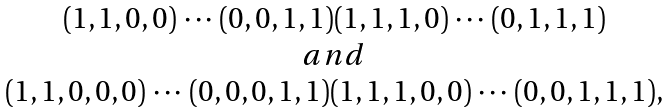Convert formula to latex. <formula><loc_0><loc_0><loc_500><loc_500>\begin{array} { c } ( 1 , 1 , 0 , 0 ) \, \cdots \, ( 0 , 0 , 1 , 1 ) ( 1 , 1 , 1 , 0 ) \, \cdots \, ( 0 , 1 , 1 , 1 ) \\ a n d \\ ( 1 , 1 , 0 , 0 , 0 ) \, \cdots \, ( 0 , 0 , 0 , 1 , 1 ) ( 1 , 1 , 1 , 0 , 0 ) \, \cdots \, ( 0 , 0 , 1 , 1 , 1 ) , \end{array}</formula> 